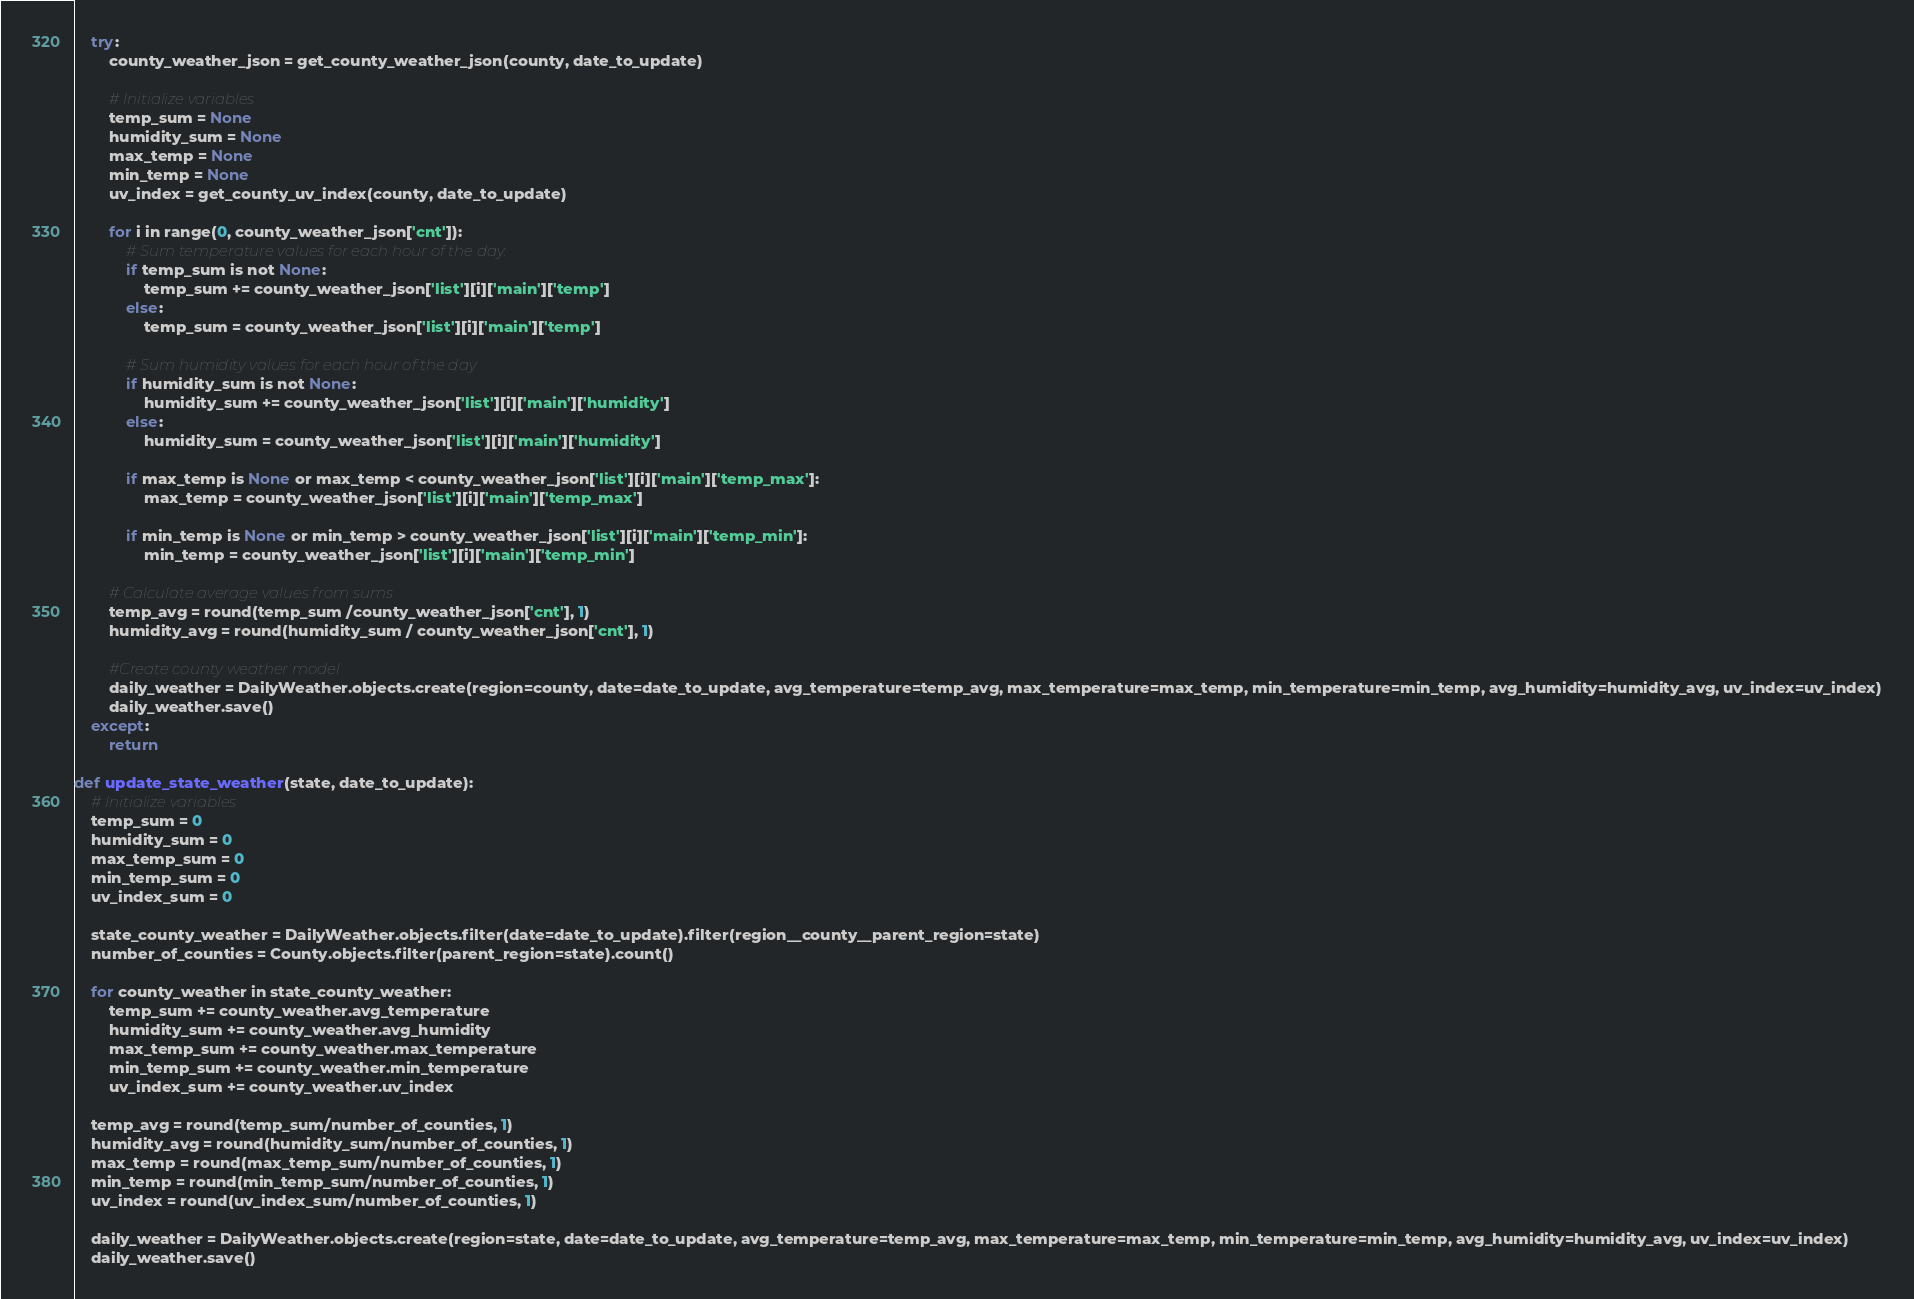<code> <loc_0><loc_0><loc_500><loc_500><_Python_>    try:
        county_weather_json = get_county_weather_json(county, date_to_update)
        
        # Initialize variables
        temp_sum = None
        humidity_sum = None
        max_temp = None
        min_temp = None
        uv_index = get_county_uv_index(county, date_to_update)

        for i in range(0, county_weather_json['cnt']):
            # Sum temperature values for each hour of the day.
            if temp_sum is not None:
                temp_sum += county_weather_json['list'][i]['main']['temp']
            else:
                temp_sum = county_weather_json['list'][i]['main']['temp']
            
            # Sum humidity values for each hour of the day
            if humidity_sum is not None:
                humidity_sum += county_weather_json['list'][i]['main']['humidity']
            else:
                humidity_sum = county_weather_json['list'][i]['main']['humidity']

            if max_temp is None or max_temp < county_weather_json['list'][i]['main']['temp_max']:
                max_temp = county_weather_json['list'][i]['main']['temp_max']

            if min_temp is None or min_temp > county_weather_json['list'][i]['main']['temp_min']:
                min_temp = county_weather_json['list'][i]['main']['temp_min']

        # Calculate average values from sums
        temp_avg = round(temp_sum /county_weather_json['cnt'], 1)
        humidity_avg = round(humidity_sum / county_weather_json['cnt'], 1)
        
        #Create county weather model
        daily_weather = DailyWeather.objects.create(region=county, date=date_to_update, avg_temperature=temp_avg, max_temperature=max_temp, min_temperature=min_temp, avg_humidity=humidity_avg, uv_index=uv_index)
        daily_weather.save()
    except:
        return

def update_state_weather(state, date_to_update):
    # Initialize variables
    temp_sum = 0
    humidity_sum = 0
    max_temp_sum = 0
    min_temp_sum = 0
    uv_index_sum = 0
    
    state_county_weather = DailyWeather.objects.filter(date=date_to_update).filter(region__county__parent_region=state)
    number_of_counties = County.objects.filter(parent_region=state).count()
    
    for county_weather in state_county_weather:
        temp_sum += county_weather.avg_temperature
        humidity_sum += county_weather.avg_humidity
        max_temp_sum += county_weather.max_temperature
        min_temp_sum += county_weather.min_temperature
        uv_index_sum += county_weather.uv_index

    temp_avg = round(temp_sum/number_of_counties, 1)
    humidity_avg = round(humidity_sum/number_of_counties, 1)
    max_temp = round(max_temp_sum/number_of_counties, 1)
    min_temp = round(min_temp_sum/number_of_counties, 1)
    uv_index = round(uv_index_sum/number_of_counties, 1)

    daily_weather = DailyWeather.objects.create(region=state, date=date_to_update, avg_temperature=temp_avg, max_temperature=max_temp, min_temperature=min_temp, avg_humidity=humidity_avg, uv_index=uv_index)
    daily_weather.save()  </code> 